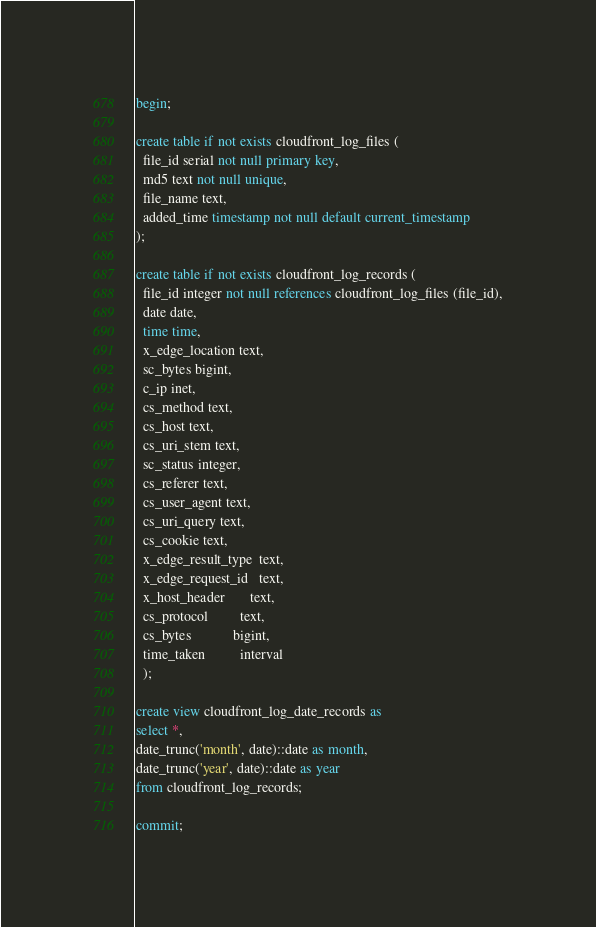Convert code to text. <code><loc_0><loc_0><loc_500><loc_500><_SQL_>begin;

create table if not exists cloudfront_log_files (
  file_id serial not null primary key,
  md5 text not null unique,
  file_name text,
  added_time timestamp not null default current_timestamp
);

create table if not exists cloudfront_log_records (
  file_id integer not null references cloudfront_log_files (file_id),
  date date,
  time time,
  x_edge_location text,
  sc_bytes bigint,
  c_ip inet,
  cs_method text,
  cs_host text,
  cs_uri_stem text,
  sc_status integer,
  cs_referer text,
  cs_user_agent text,
  cs_uri_query text,
  cs_cookie text,
  x_edge_result_type  text,
  x_edge_request_id   text,
  x_host_header       text,
  cs_protocol         text,
  cs_bytes            bigint,
  time_taken          interval
  );

create view cloudfront_log_date_records as
select *,
date_trunc('month', date)::date as month,
date_trunc('year', date)::date as year
from cloudfront_log_records;
  
commit;
</code> 